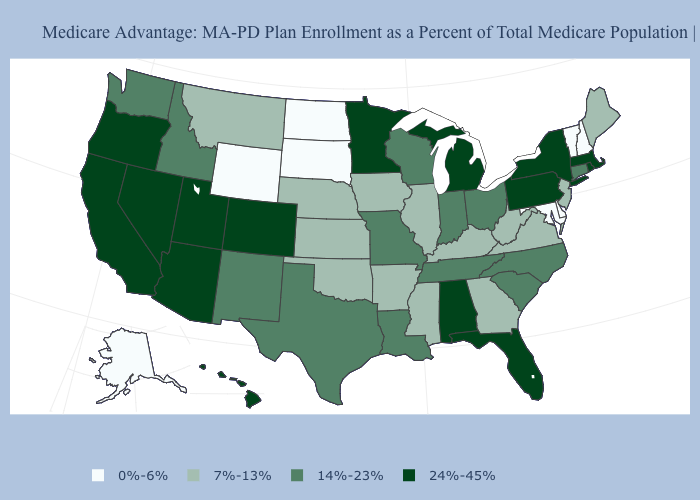Which states have the lowest value in the USA?
Keep it brief. Alaska, Delaware, Maryland, North Dakota, New Hampshire, South Dakota, Vermont, Wyoming. What is the lowest value in the MidWest?
Answer briefly. 0%-6%. Which states hav the highest value in the West?
Quick response, please. Arizona, California, Colorado, Hawaii, Nevada, Oregon, Utah. What is the lowest value in the MidWest?
Keep it brief. 0%-6%. Name the states that have a value in the range 0%-6%?
Concise answer only. Alaska, Delaware, Maryland, North Dakota, New Hampshire, South Dakota, Vermont, Wyoming. Is the legend a continuous bar?
Give a very brief answer. No. Does Mississippi have the same value as Georgia?
Write a very short answer. Yes. What is the lowest value in the USA?
Concise answer only. 0%-6%. What is the lowest value in states that border Louisiana?
Write a very short answer. 7%-13%. Name the states that have a value in the range 24%-45%?
Give a very brief answer. Alabama, Arizona, California, Colorado, Florida, Hawaii, Massachusetts, Michigan, Minnesota, Nevada, New York, Oregon, Pennsylvania, Rhode Island, Utah. Name the states that have a value in the range 7%-13%?
Quick response, please. Arkansas, Georgia, Iowa, Illinois, Kansas, Kentucky, Maine, Mississippi, Montana, Nebraska, New Jersey, Oklahoma, Virginia, West Virginia. Which states have the lowest value in the USA?
Keep it brief. Alaska, Delaware, Maryland, North Dakota, New Hampshire, South Dakota, Vermont, Wyoming. What is the highest value in the Northeast ?
Be succinct. 24%-45%. Name the states that have a value in the range 24%-45%?
Write a very short answer. Alabama, Arizona, California, Colorado, Florida, Hawaii, Massachusetts, Michigan, Minnesota, Nevada, New York, Oregon, Pennsylvania, Rhode Island, Utah. Does Missouri have the highest value in the MidWest?
Quick response, please. No. 